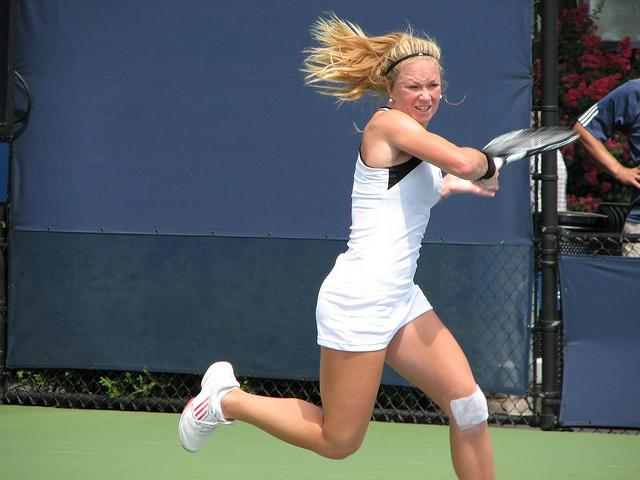What happened to this players left knee? Please explain your reasoning. cut. The player is wearing a bandage on their knee which might be the result of answer a. 